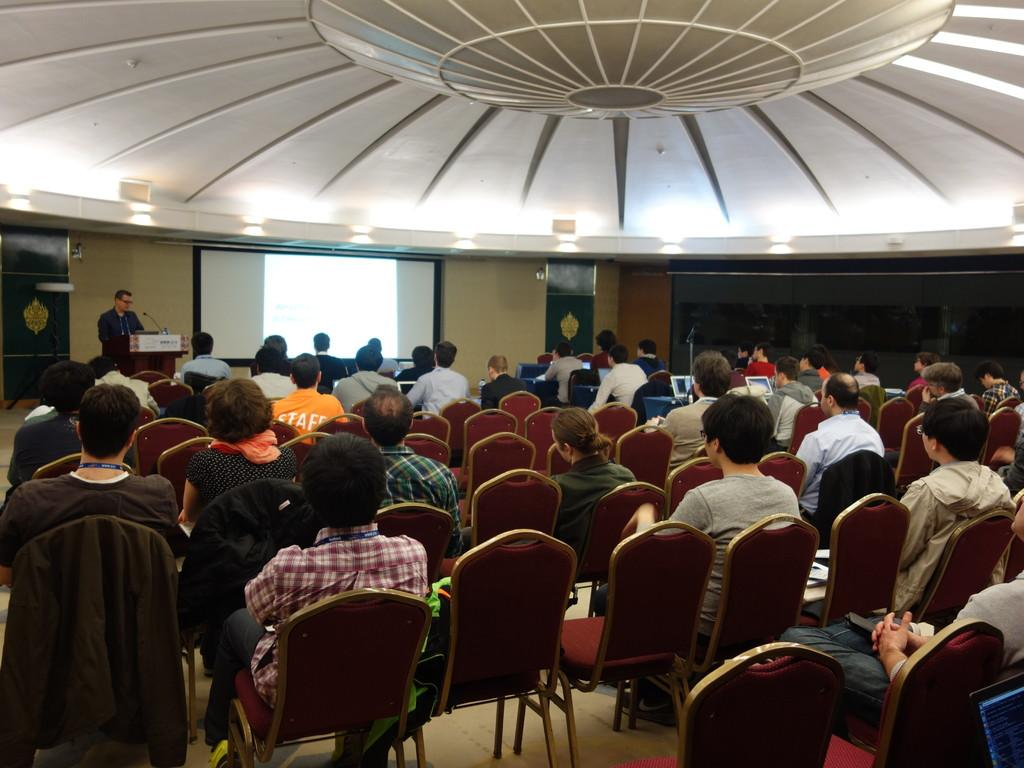What are the people in the image doing? The people in the image are sitting on chairs. What can be seen behind the person standing in the image? There is a screen visible in the image. What is the person standing in front of in the image? The person is standing in front of a podium. What type of scarf is the actor wearing in the image? There is no actor or scarf present in the image. How many pigs can be seen on the screen in the image? There are no pigs visible in the image, and the screen is not described in enough detail to determine its content. 